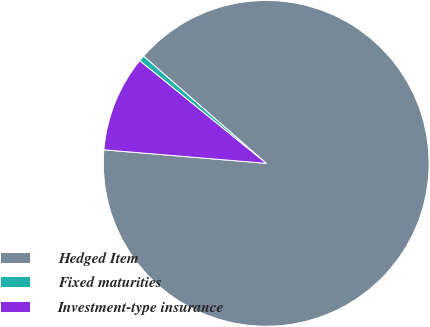<chart> <loc_0><loc_0><loc_500><loc_500><pie_chart><fcel>Hedged Item<fcel>Fixed maturities<fcel>Investment-type insurance<nl><fcel>89.9%<fcel>0.59%<fcel>9.52%<nl></chart> 